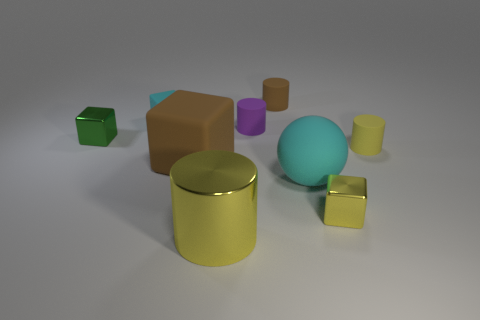Subtract 1 cylinders. How many cylinders are left? 3 Add 1 brown metallic things. How many objects exist? 10 Subtract all blocks. How many objects are left? 5 Add 5 brown matte cylinders. How many brown matte cylinders exist? 6 Subtract 0 gray cylinders. How many objects are left? 9 Subtract all tiny brown things. Subtract all big brown blocks. How many objects are left? 7 Add 7 big cyan matte spheres. How many big cyan matte spheres are left? 8 